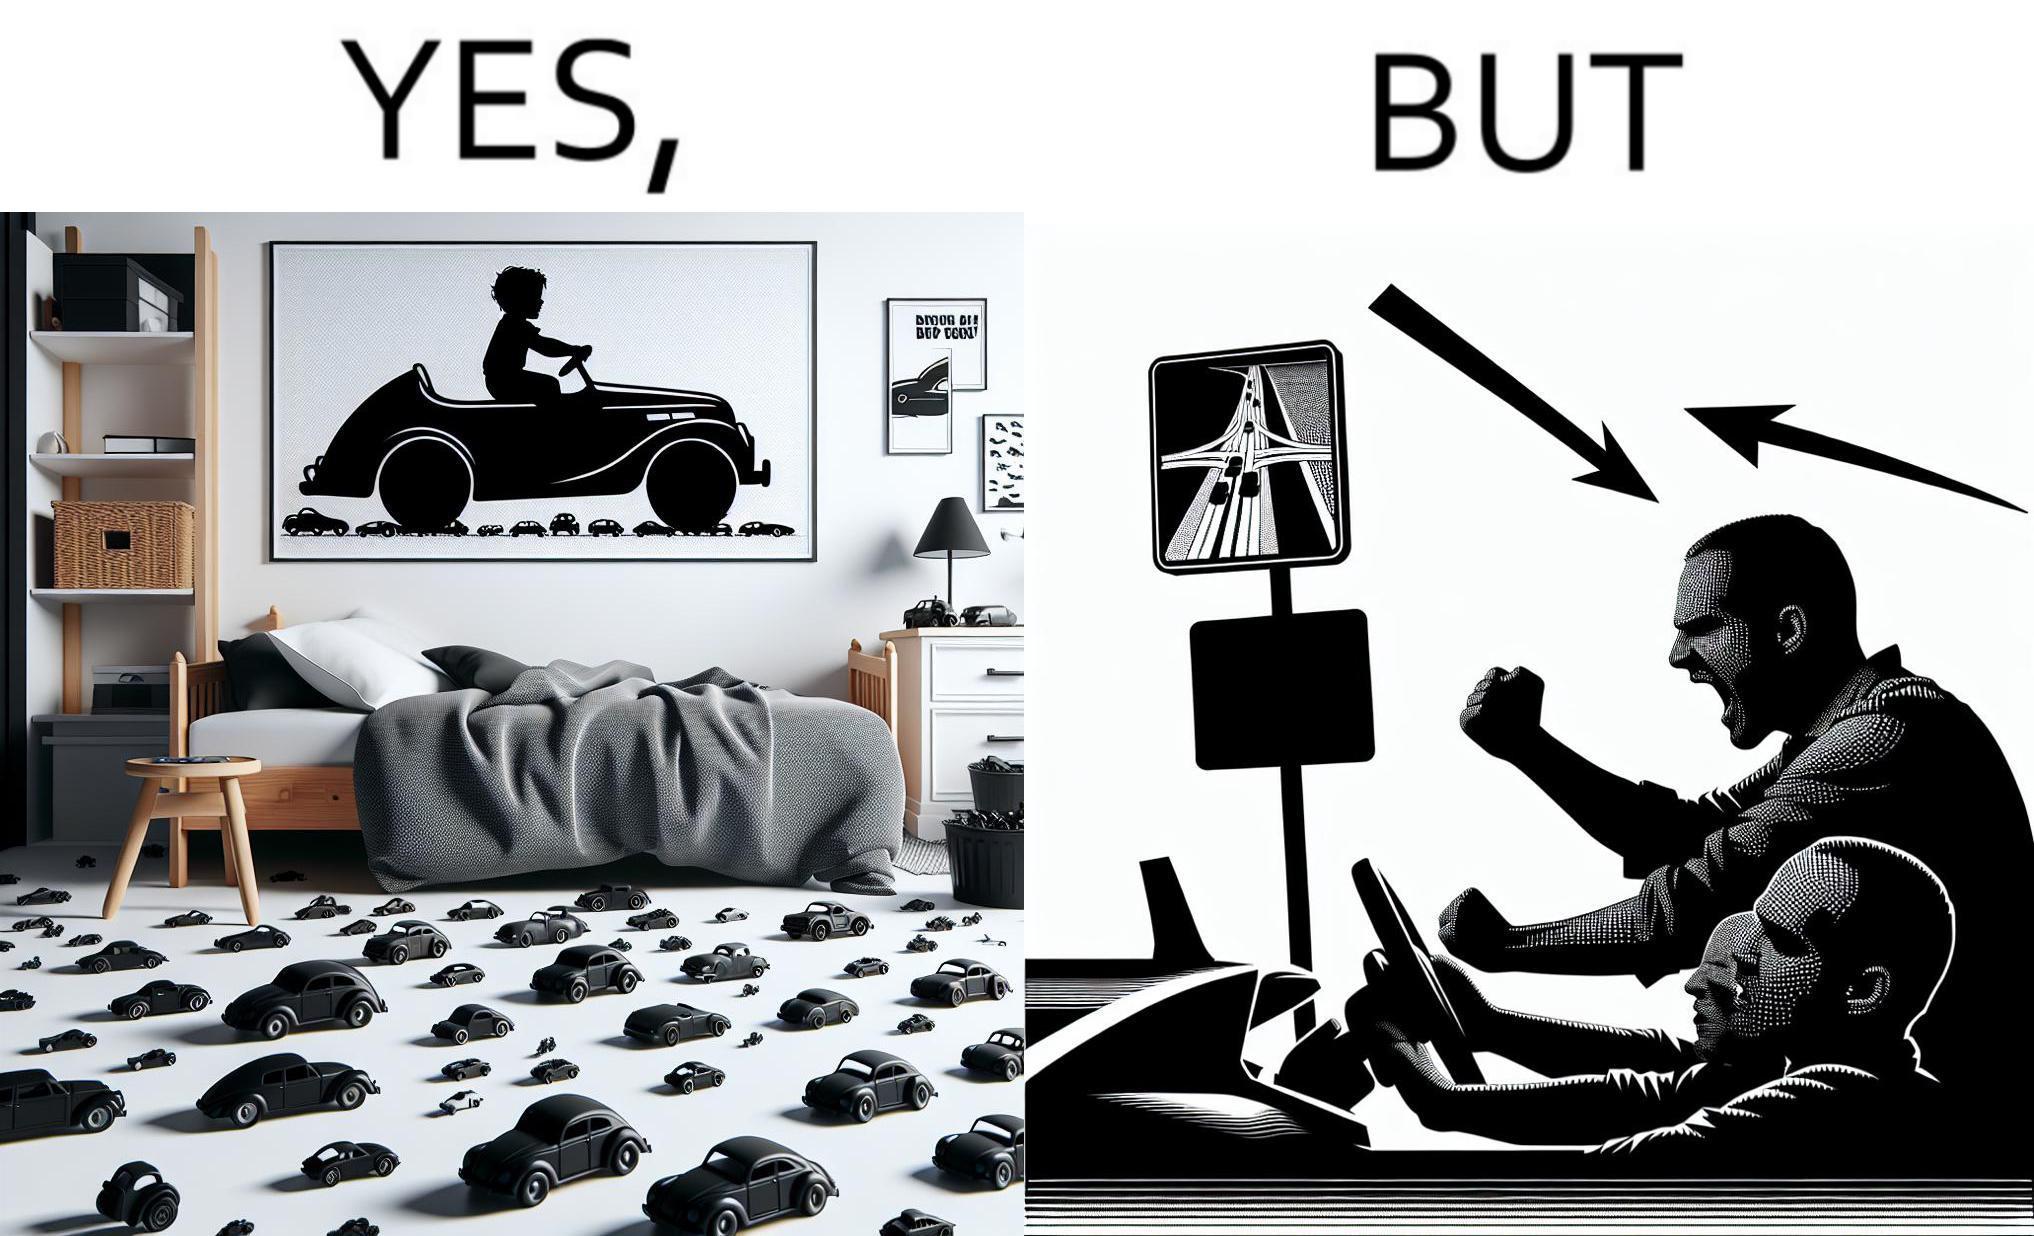What is shown in the left half versus the right half of this image? In the left part of the image: The image shows the bedroom of a child with various small toy cars and posters of cars on the wall. The child in the picture is also riding a bigger toy car. In the right part of the image: The image shows a man annoyed by the slow traffic on his way as shown on the map while he is driving. 